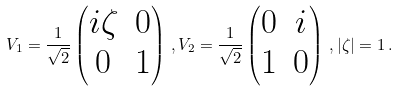<formula> <loc_0><loc_0><loc_500><loc_500>V _ { 1 } = \frac { 1 } { \sqrt { 2 } } \left ( \begin{matrix} i \zeta & 0 \\ 0 & 1 \end{matrix} \right ) \, , V _ { 2 } = \frac { 1 } { \sqrt { 2 } } \left ( \begin{matrix} 0 & i \\ 1 & 0 \end{matrix} \right ) \, , | \zeta | = 1 \, .</formula> 